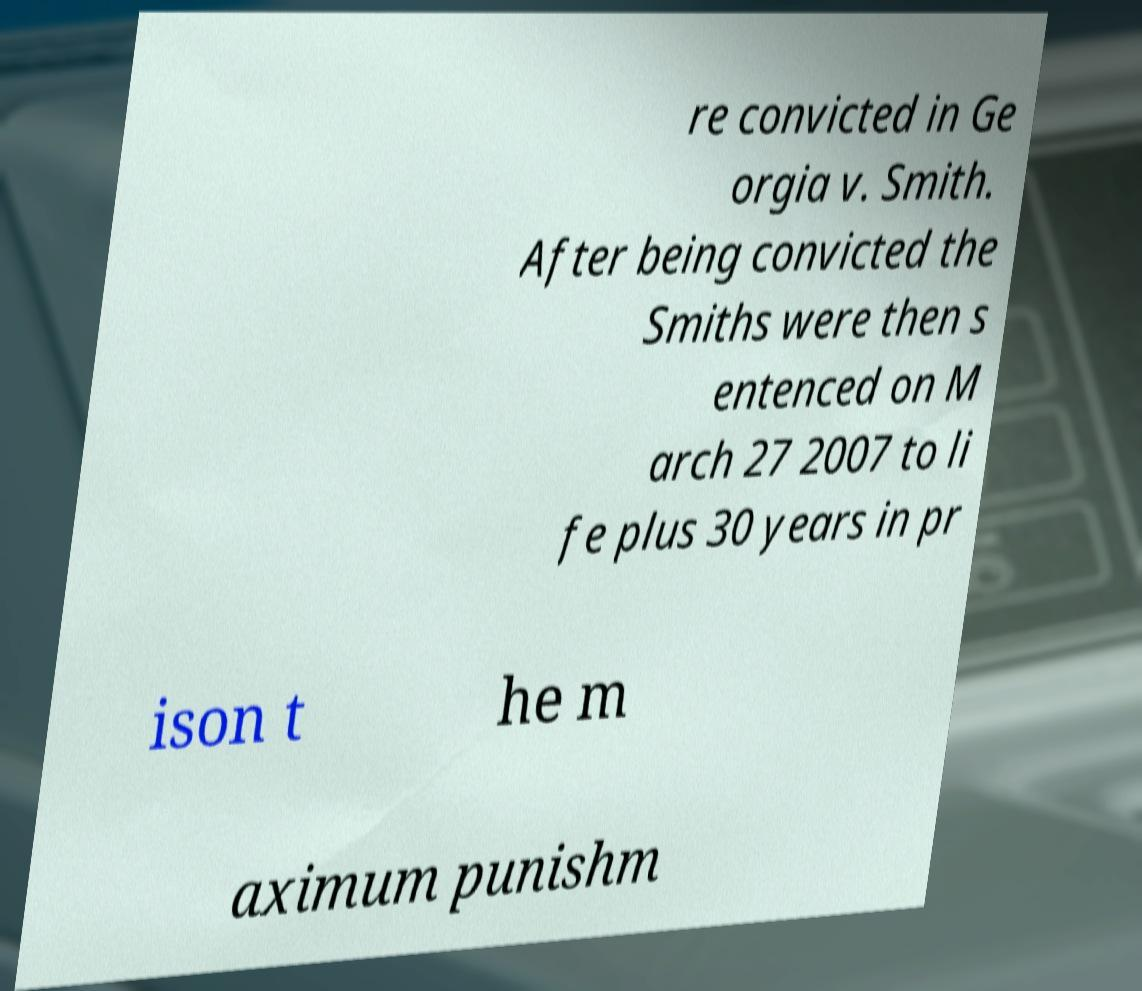Please read and relay the text visible in this image. What does it say? re convicted in Ge orgia v. Smith. After being convicted the Smiths were then s entenced on M arch 27 2007 to li fe plus 30 years in pr ison t he m aximum punishm 